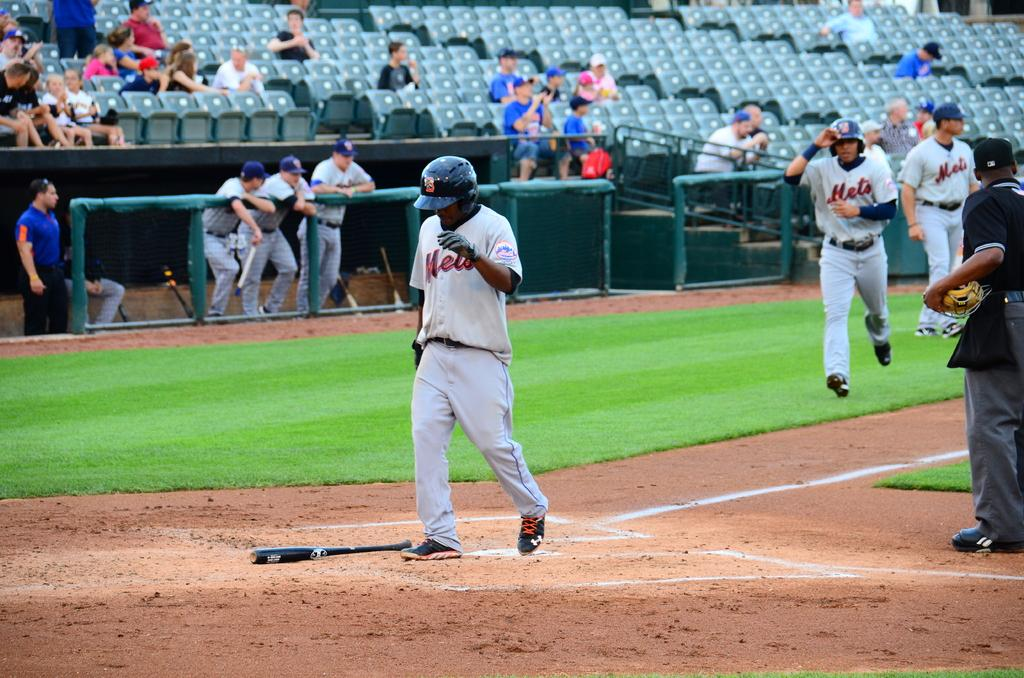<image>
Offer a succinct explanation of the picture presented. A baseball player wearing a Net's jersey crosses a base. 